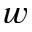Convert formula to latex. <formula><loc_0><loc_0><loc_500><loc_500>w</formula> 